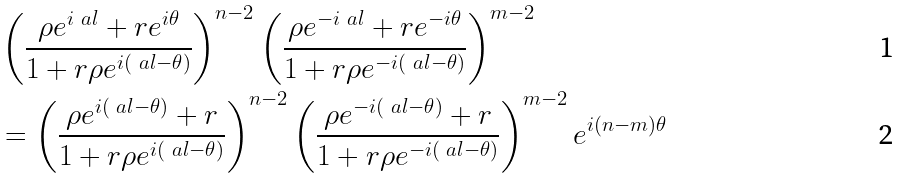Convert formula to latex. <formula><loc_0><loc_0><loc_500><loc_500>& \left ( \frac { \rho e ^ { i \ a l } + r e ^ { i \theta } } { 1 + r \rho e ^ { i ( \ a l - \theta ) } } \right ) ^ { n - 2 } \left ( \frac { \rho e ^ { - i \ a l } + r e ^ { - i \theta } } { 1 + r \rho e ^ { - i ( \ a l - \theta ) } } \right ) ^ { m - 2 } \\ & = \left ( \frac { \rho e ^ { i ( \ a l - \theta ) } + r } { 1 + r \rho e ^ { i ( \ a l - \theta ) } } \right ) ^ { n - 2 } \left ( \frac { \rho e ^ { - i ( \ a l - \theta ) } + r } { 1 + r \rho e ^ { - i ( \ a l - \theta ) } } \right ) ^ { m - 2 } e ^ { i ( n - m ) \theta }</formula> 